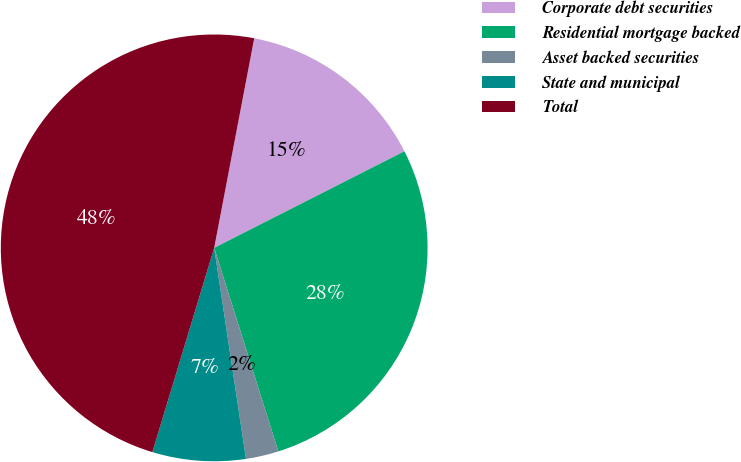Convert chart to OTSL. <chart><loc_0><loc_0><loc_500><loc_500><pie_chart><fcel>Corporate debt securities<fcel>Residential mortgage backed<fcel>Asset backed securities<fcel>State and municipal<fcel>Total<nl><fcel>14.52%<fcel>27.62%<fcel>2.48%<fcel>7.06%<fcel>48.33%<nl></chart> 